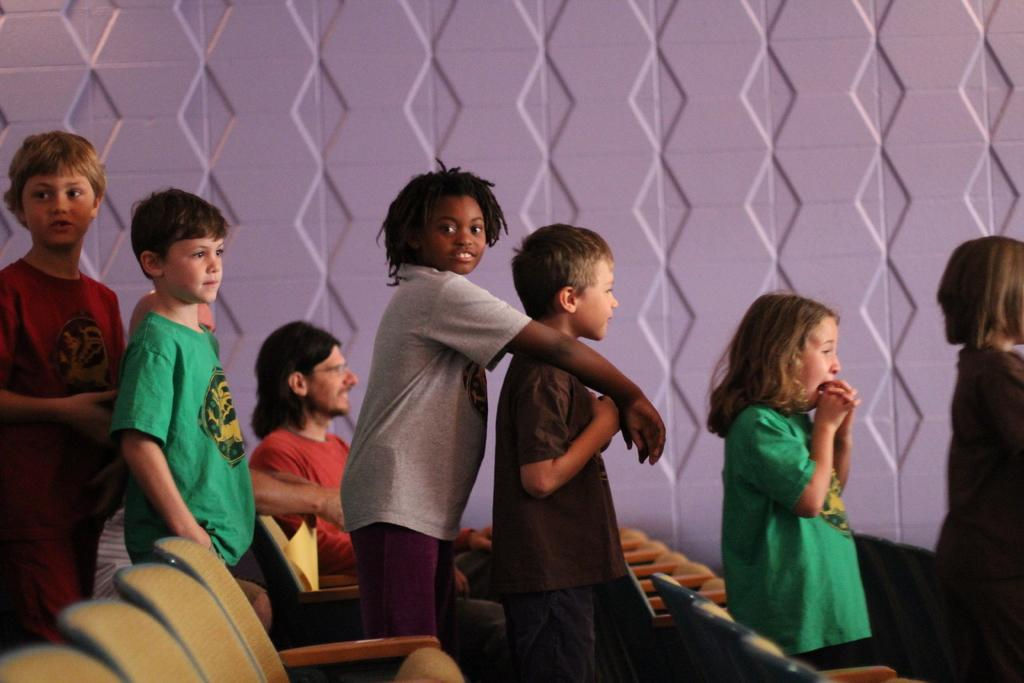How many people are in the image? There is a group of people in the image. What are some of the people in the image doing? Some people are standing, and a man is sitting on a chair. Are there any seats visible in the image? Yes, there are seats in the image. What can be seen in the background of the image? There is a wall in the background of the image. What type of card is the man holding in the image? There is no card present in the image. What kind of art can be seen on the wall in the image? There is no art visible on the wall in the image. 